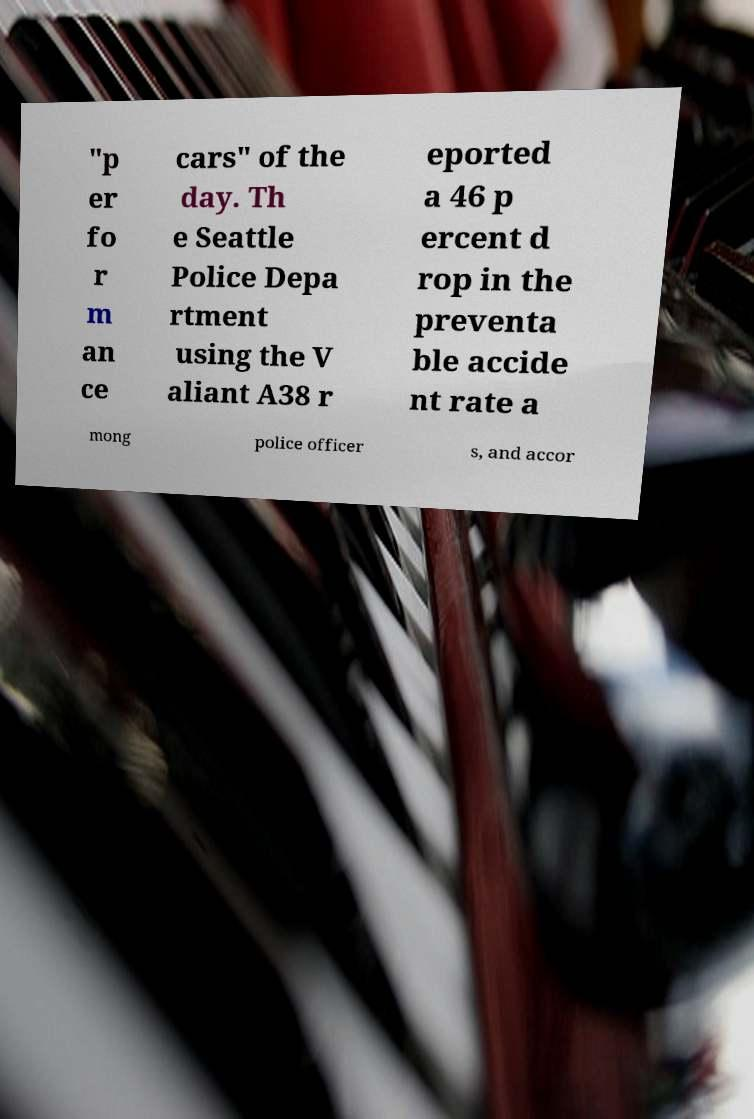I need the written content from this picture converted into text. Can you do that? "p er fo r m an ce cars" of the day. Th e Seattle Police Depa rtment using the V aliant A38 r eported a 46 p ercent d rop in the preventa ble accide nt rate a mong police officer s, and accor 